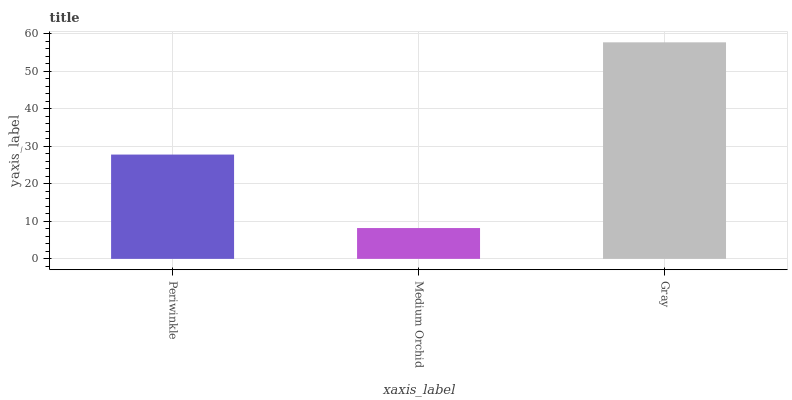Is Medium Orchid the minimum?
Answer yes or no. Yes. Is Gray the maximum?
Answer yes or no. Yes. Is Gray the minimum?
Answer yes or no. No. Is Medium Orchid the maximum?
Answer yes or no. No. Is Gray greater than Medium Orchid?
Answer yes or no. Yes. Is Medium Orchid less than Gray?
Answer yes or no. Yes. Is Medium Orchid greater than Gray?
Answer yes or no. No. Is Gray less than Medium Orchid?
Answer yes or no. No. Is Periwinkle the high median?
Answer yes or no. Yes. Is Periwinkle the low median?
Answer yes or no. Yes. Is Medium Orchid the high median?
Answer yes or no. No. Is Medium Orchid the low median?
Answer yes or no. No. 